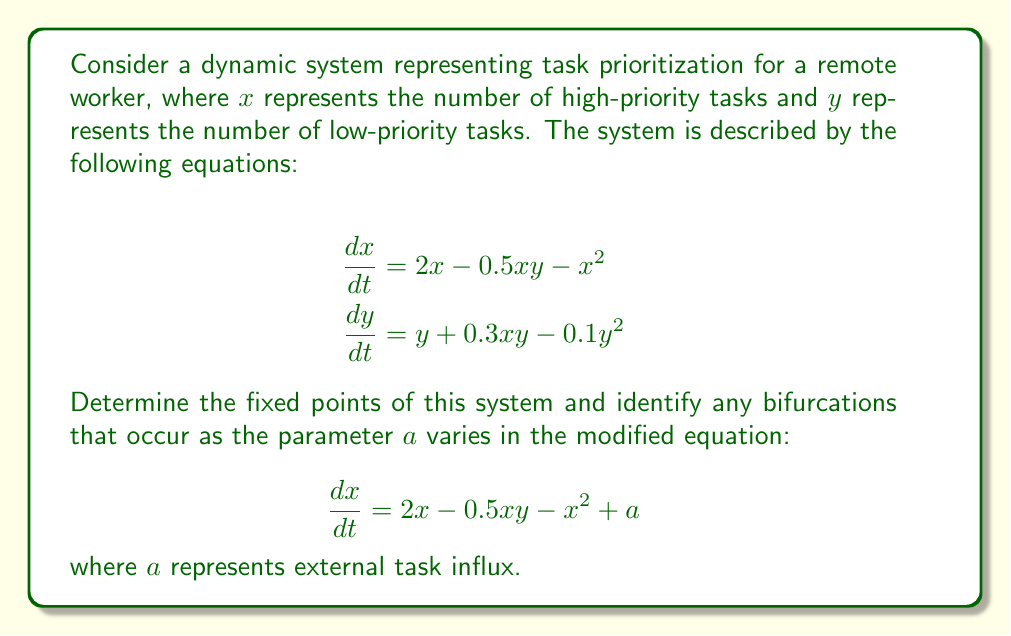Teach me how to tackle this problem. Step 1: Find the fixed points of the original system
Set $\frac{dx}{dt} = 0$ and $\frac{dy}{dt} = 0$:

$$2x - 0.5xy - x^2 = 0$$
$$y + 0.3xy - 0.1y^2 = 0$$

From the first equation:
$$x(2 - 0.5y - x) = 0$$
So, either $x = 0$ or $2 - 0.5y - x = 0$

From the second equation:
$$y(1 + 0.3x - 0.1y) = 0$$
So, either $y = 0$ or $1 + 0.3x - 0.1y = 0$

Fixed point 1: $(x, y) = (0, 0)$
Fixed point 2: Solving $2 - 0.5y - x = 0$ and $1 + 0.3x - 0.1y = 0$ simultaneously:
$$x = 2 - 0.5y$$
$$1 + 0.3(2 - 0.5y) - 0.1y = 0$$
$$1.6 - 0.15y - 0.1y = 0$$
$$1.6 = 0.25y$$
$$y = 6.4$$
$$x = 2 - 0.5(6.4) = 2 - 3.2 = -1.2$$

So, the second fixed point is $(x, y) = (-1.2, 6.4)$

Step 2: Analyze bifurcations in the modified system
For the modified system with parameter $a$:

$$\frac{dx}{dt} = 2x - 0.5xy - x^2 + a$$

Set $\frac{dx}{dt} = 0$:

$$2x - 0.5xy - x^2 + a = 0$$

For $y = 0$ (considering only the x-axis):

$$2x - x^2 + a = 0$$
$$x^2 - 2x - a = 0$$

This is a quadratic equation in $x$. A bifurcation occurs when this equation has a double root, which happens when its discriminant is zero:

$$\Delta = b^2 - 4ac = (-2)^2 - 4(1)(-a) = 4 + 4a = 0$$
$$4a = -4$$
$$a = -1$$

At $a = -1$, a saddle-node bifurcation occurs. For $a < -1$, there are no fixed points on the x-axis. For $a > -1$, there are two fixed points on the x-axis.
Answer: Fixed points: $(0, 0)$ and $(-1.2, 6.4)$. Saddle-node bifurcation at $a = -1$. 